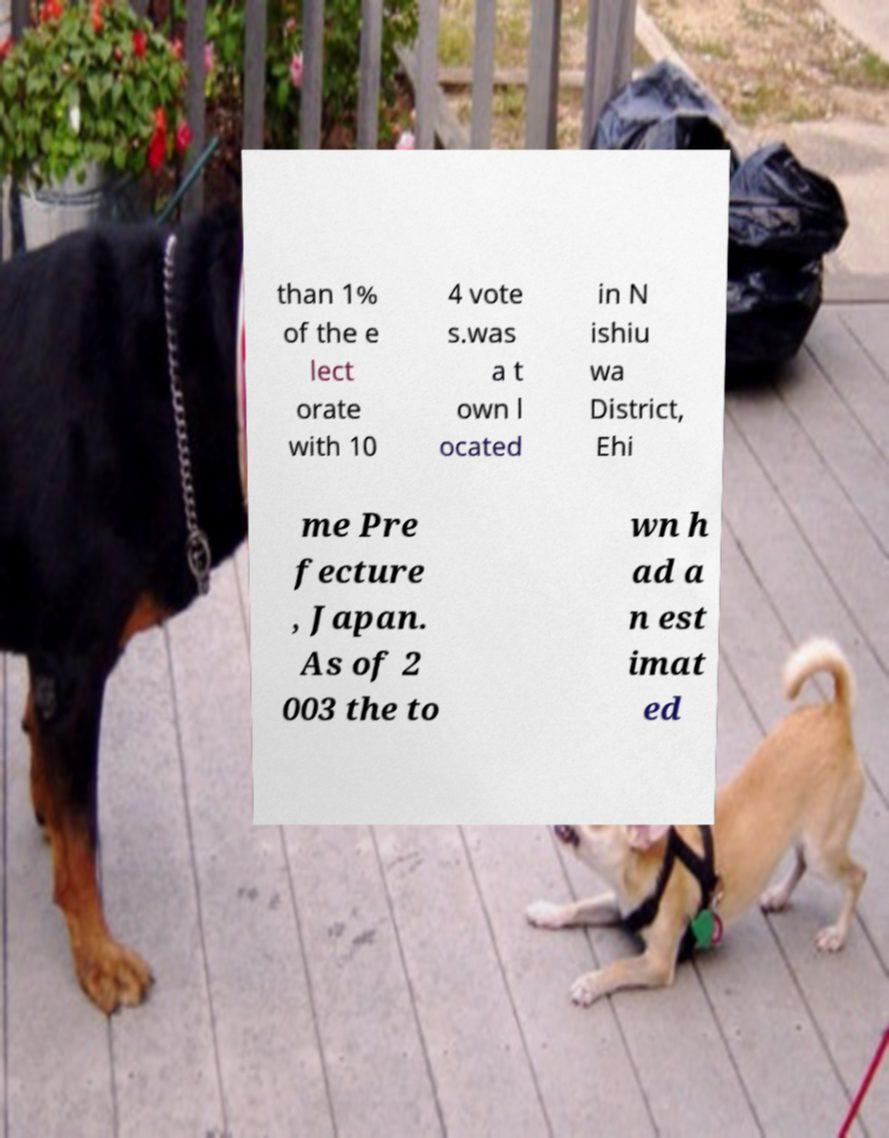For documentation purposes, I need the text within this image transcribed. Could you provide that? than 1% of the e lect orate with 10 4 vote s.was a t own l ocated in N ishiu wa District, Ehi me Pre fecture , Japan. As of 2 003 the to wn h ad a n est imat ed 